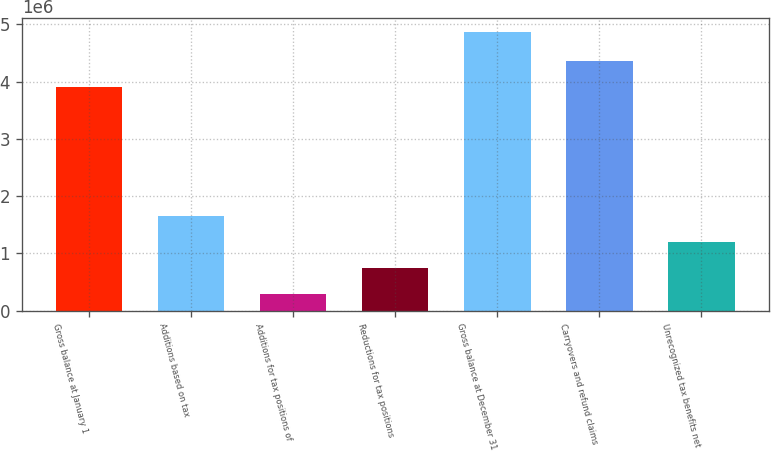Convert chart. <chart><loc_0><loc_0><loc_500><loc_500><bar_chart><fcel>Gross balance at January 1<fcel>Additions based on tax<fcel>Additions for tax positions of<fcel>Reductions for tax positions<fcel>Gross balance at December 31<fcel>Carryovers and refund claims<fcel>Unrecognized tax benefits net<nl><fcel>3.90986e+06<fcel>1.66013e+06<fcel>283683<fcel>742499<fcel>4.87185e+06<fcel>4.36867e+06<fcel>1.20132e+06<nl></chart> 